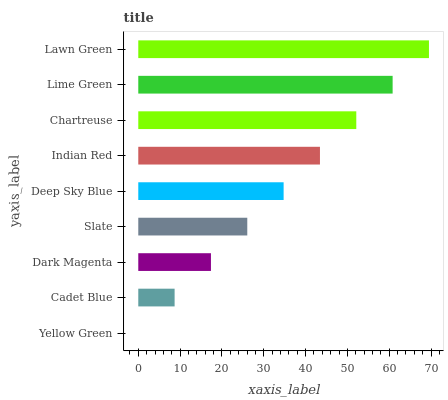Is Yellow Green the minimum?
Answer yes or no. Yes. Is Lawn Green the maximum?
Answer yes or no. Yes. Is Cadet Blue the minimum?
Answer yes or no. No. Is Cadet Blue the maximum?
Answer yes or no. No. Is Cadet Blue greater than Yellow Green?
Answer yes or no. Yes. Is Yellow Green less than Cadet Blue?
Answer yes or no. Yes. Is Yellow Green greater than Cadet Blue?
Answer yes or no. No. Is Cadet Blue less than Yellow Green?
Answer yes or no. No. Is Deep Sky Blue the high median?
Answer yes or no. Yes. Is Deep Sky Blue the low median?
Answer yes or no. Yes. Is Lawn Green the high median?
Answer yes or no. No. Is Chartreuse the low median?
Answer yes or no. No. 